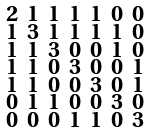Convert formula to latex. <formula><loc_0><loc_0><loc_500><loc_500>\begin{smallmatrix} 2 & 1 & 1 & 1 & 1 & 0 & 0 \\ 1 & 3 & 1 & 1 & 1 & 1 & 0 \\ 1 & 1 & 3 & 0 & 0 & 1 & 0 \\ 1 & 1 & 0 & 3 & 0 & 0 & 1 \\ 1 & 1 & 0 & 0 & 3 & 0 & 1 \\ 0 & 1 & 1 & 0 & 0 & 3 & 0 \\ 0 & 0 & 0 & 1 & 1 & 0 & 3 \end{smallmatrix}</formula> 